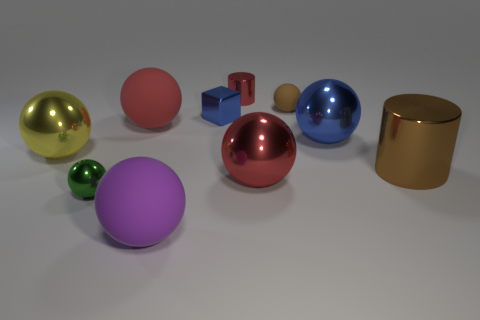Which objects in the image are closest to the viewer? The objects closest to the viewer are the large purple sphere in the foreground, followed by the shiny yellow sphere and the large pink sphere. Can you describe their relative sizes and colors? Certainly! The large purple sphere occupies the most visual space in the foreground and has a matte lavender color. The shiny yellow sphere next to it is slightly smaller and has a reflective gold color. The large pink sphere, which is matte like the purple one, is similar in size but slightly further away. 